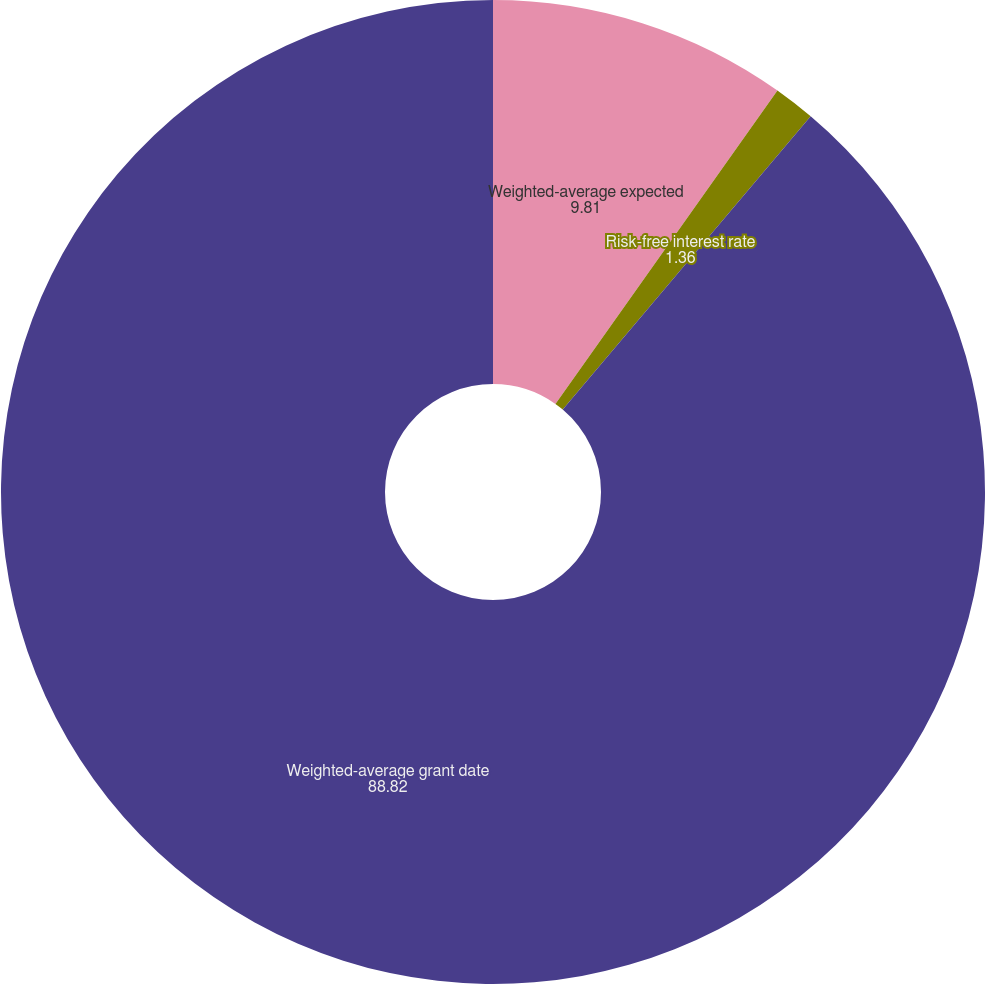Convert chart. <chart><loc_0><loc_0><loc_500><loc_500><pie_chart><fcel>Weighted-average expected<fcel>Risk-free interest rate<fcel>Weighted-average grant date<nl><fcel>9.81%<fcel>1.36%<fcel>88.82%<nl></chart> 